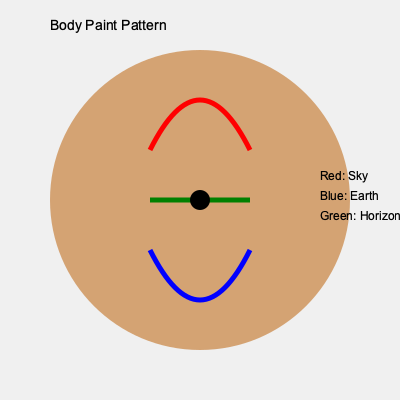In the context of the film's depiction of indigenous body paint patterns, what does the combination of curved red and blue lines with a straight green line across the center likely symbolize in the community's cosmology? To decode the meaning of this ritualistic body paint pattern, we need to analyze its components and their arrangement:

1. Shape: The overall circular shape represents wholeness or the universe.

2. Red curved line at the top:
   - Color: Red often symbolizes the sky, sun, or celestial realm in many indigenous cultures.
   - Shape: The upward curve suggests an arching or domed structure.

3. Blue curved line at the bottom:
   - Color: Blue typically represents water or earth in indigenous symbolism.
   - Shape: The downward curve mirrors the upper curve, creating balance.

4. Green straight line in the center:
   - Color: Green often symbolizes plant life or the natural world.
   - Shape: The straight line suggests a boundary or division.

5. Arrangement:
   - The red (sky) is above, and the blue (earth) is below.
   - The green line separates them, acting as an intermediary.

Given this analysis, the pattern likely represents the community's view of the cosmos:
- The upper realm (sky/heavens)
- The lower realm (earth/underworld)
- The middle realm (the horizon or natural world that connects the two)

This three-tiered cosmology is common in many indigenous belief systems, where the natural world serves as a bridge between the celestial and terrestrial realms.
Answer: Three-tiered cosmos: sky, earth, and connecting horizon 